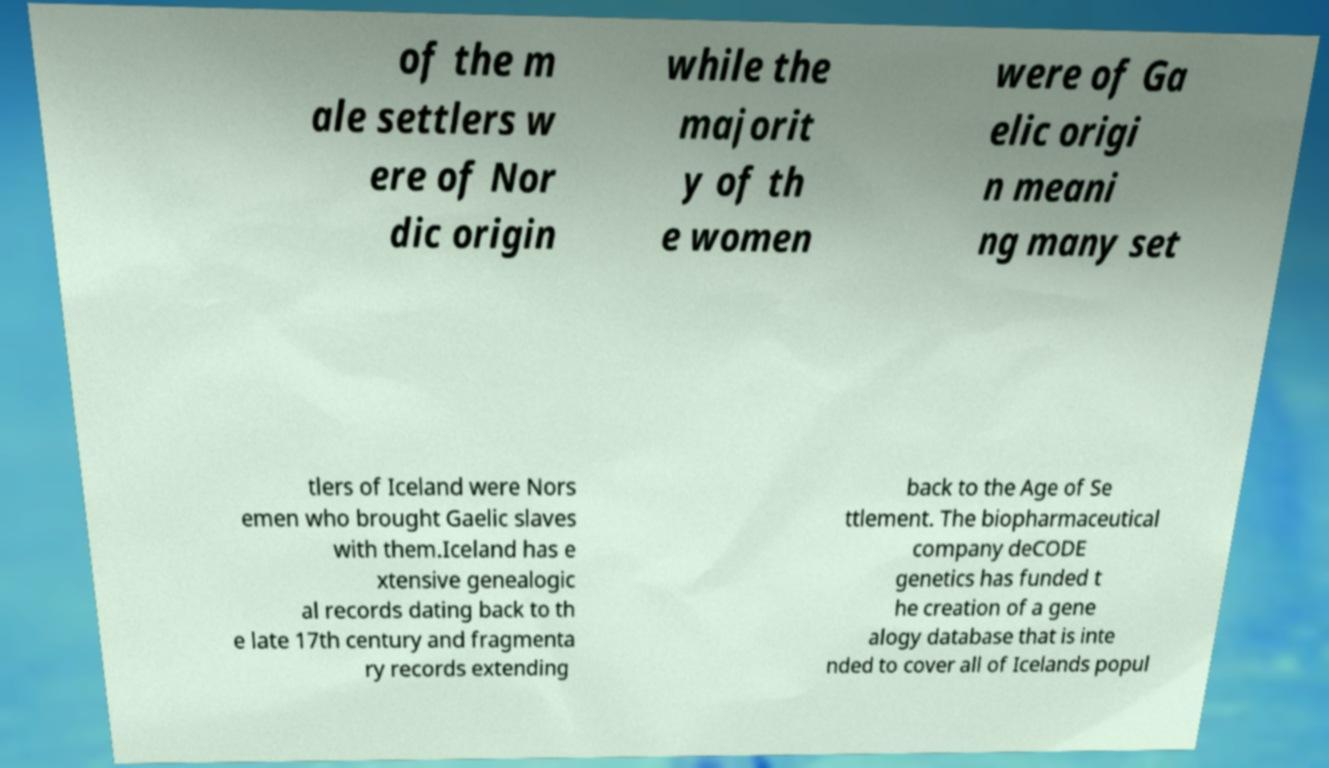Please read and relay the text visible in this image. What does it say? of the m ale settlers w ere of Nor dic origin while the majorit y of th e women were of Ga elic origi n meani ng many set tlers of Iceland were Nors emen who brought Gaelic slaves with them.Iceland has e xtensive genealogic al records dating back to th e late 17th century and fragmenta ry records extending back to the Age of Se ttlement. The biopharmaceutical company deCODE genetics has funded t he creation of a gene alogy database that is inte nded to cover all of Icelands popul 